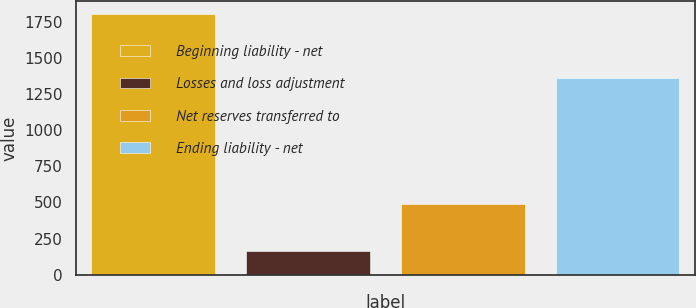Convert chart to OTSL. <chart><loc_0><loc_0><loc_500><loc_500><bar_chart><fcel>Beginning liability - net<fcel>Losses and loss adjustment<fcel>Net reserves transferred to<fcel>Ending liability - net<nl><fcel>1803<fcel>165<fcel>492.6<fcel>1363<nl></chart> 